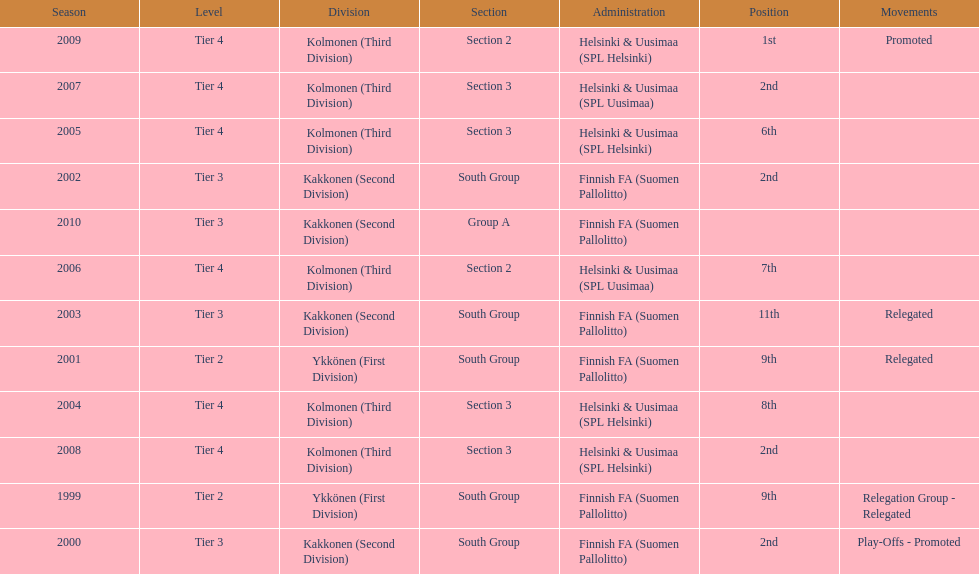Which was the only kolmonen whose movements were promoted? 2009. 